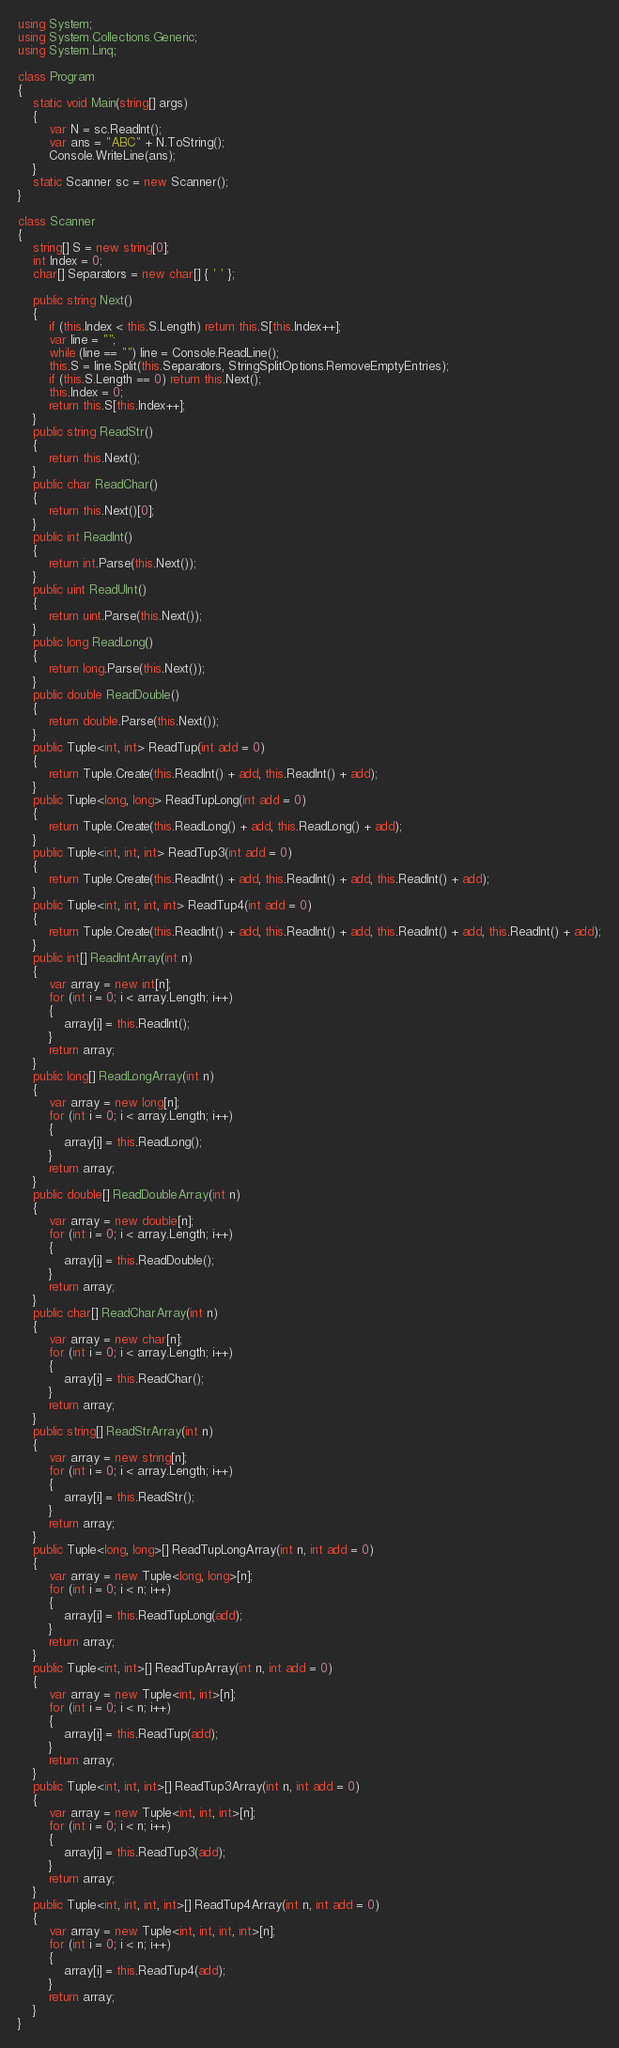Convert code to text. <code><loc_0><loc_0><loc_500><loc_500><_C#_>using System;
using System.Collections.Generic;
using System.Linq;

class Program
{
    static void Main(string[] args)
    {
        var N = sc.ReadInt();
        var ans = "ABC" + N.ToString();
        Console.WriteLine(ans);
    }
    static Scanner sc = new Scanner();
}

class Scanner
{
    string[] S = new string[0];
    int Index = 0;
    char[] Separators = new char[] { ' ' };

    public string Next()
    {
        if (this.Index < this.S.Length) return this.S[this.Index++];
        var line = "";
        while (line == "") line = Console.ReadLine();
        this.S = line.Split(this.Separators, StringSplitOptions.RemoveEmptyEntries);
        if (this.S.Length == 0) return this.Next();
        this.Index = 0;
        return this.S[this.Index++];
    }
    public string ReadStr()
    {
        return this.Next();
    }
    public char ReadChar()
    {
        return this.Next()[0];
    }
    public int ReadInt()
    {
        return int.Parse(this.Next());
    }
    public uint ReadUInt()
    {
        return uint.Parse(this.Next());
    }
    public long ReadLong()
    {
        return long.Parse(this.Next());
    }
    public double ReadDouble()
    {
        return double.Parse(this.Next());
    }
    public Tuple<int, int> ReadTup(int add = 0)
    {
        return Tuple.Create(this.ReadInt() + add, this.ReadInt() + add);
    }
    public Tuple<long, long> ReadTupLong(int add = 0)
    {
        return Tuple.Create(this.ReadLong() + add, this.ReadLong() + add);
    }
    public Tuple<int, int, int> ReadTup3(int add = 0)
    {
        return Tuple.Create(this.ReadInt() + add, this.ReadInt() + add, this.ReadInt() + add);
    }
    public Tuple<int, int, int, int> ReadTup4(int add = 0)
    {
        return Tuple.Create(this.ReadInt() + add, this.ReadInt() + add, this.ReadInt() + add, this.ReadInt() + add);
    }
    public int[] ReadIntArray(int n)
    {
        var array = new int[n];
        for (int i = 0; i < array.Length; i++)
        {
            array[i] = this.ReadInt();
        }
        return array;
    }
    public long[] ReadLongArray(int n)
    {
        var array = new long[n];
        for (int i = 0; i < array.Length; i++)
        {
            array[i] = this.ReadLong();
        }
        return array;
    }
    public double[] ReadDoubleArray(int n)
    {
        var array = new double[n];
        for (int i = 0; i < array.Length; i++)
        {
            array[i] = this.ReadDouble();
        }
        return array;
    }
    public char[] ReadCharArray(int n)
    {
        var array = new char[n];
        for (int i = 0; i < array.Length; i++)
        {
            array[i] = this.ReadChar();
        }
        return array;
    }
    public string[] ReadStrArray(int n)
    {
        var array = new string[n];
        for (int i = 0; i < array.Length; i++)
        {
            array[i] = this.ReadStr();
        }
        return array;
    }
    public Tuple<long, long>[] ReadTupLongArray(int n, int add = 0)
    {
        var array = new Tuple<long, long>[n];
        for (int i = 0; i < n; i++)
        {
            array[i] = this.ReadTupLong(add);
        }
        return array;
    }
    public Tuple<int, int>[] ReadTupArray(int n, int add = 0)
    {
        var array = new Tuple<int, int>[n];
        for (int i = 0; i < n; i++)
        {
            array[i] = this.ReadTup(add);
        }
        return array;
    }
    public Tuple<int, int, int>[] ReadTup3Array(int n, int add = 0)
    {
        var array = new Tuple<int, int, int>[n];
        for (int i = 0; i < n; i++)
        {
            array[i] = this.ReadTup3(add);
        }
        return array;
    }
    public Tuple<int, int, int, int>[] ReadTup4Array(int n, int add = 0)
    {
        var array = new Tuple<int, int, int, int>[n];
        for (int i = 0; i < n; i++)
        {
            array[i] = this.ReadTup4(add);
        }
        return array;
    }
}
</code> 